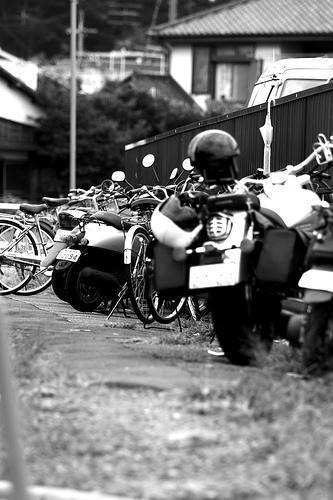How many wheels does each bike have?
Give a very brief answer. 2. 